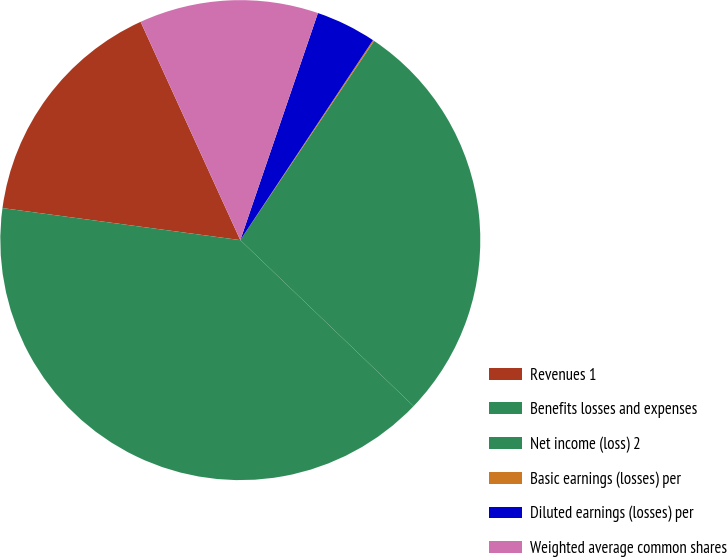Convert chart. <chart><loc_0><loc_0><loc_500><loc_500><pie_chart><fcel>Revenues 1<fcel>Benefits losses and expenses<fcel>Net income (loss) 2<fcel>Basic earnings (losses) per<fcel>Diluted earnings (losses) per<fcel>Weighted average common shares<nl><fcel>16.05%<fcel>39.97%<fcel>27.75%<fcel>0.09%<fcel>4.08%<fcel>12.06%<nl></chart> 